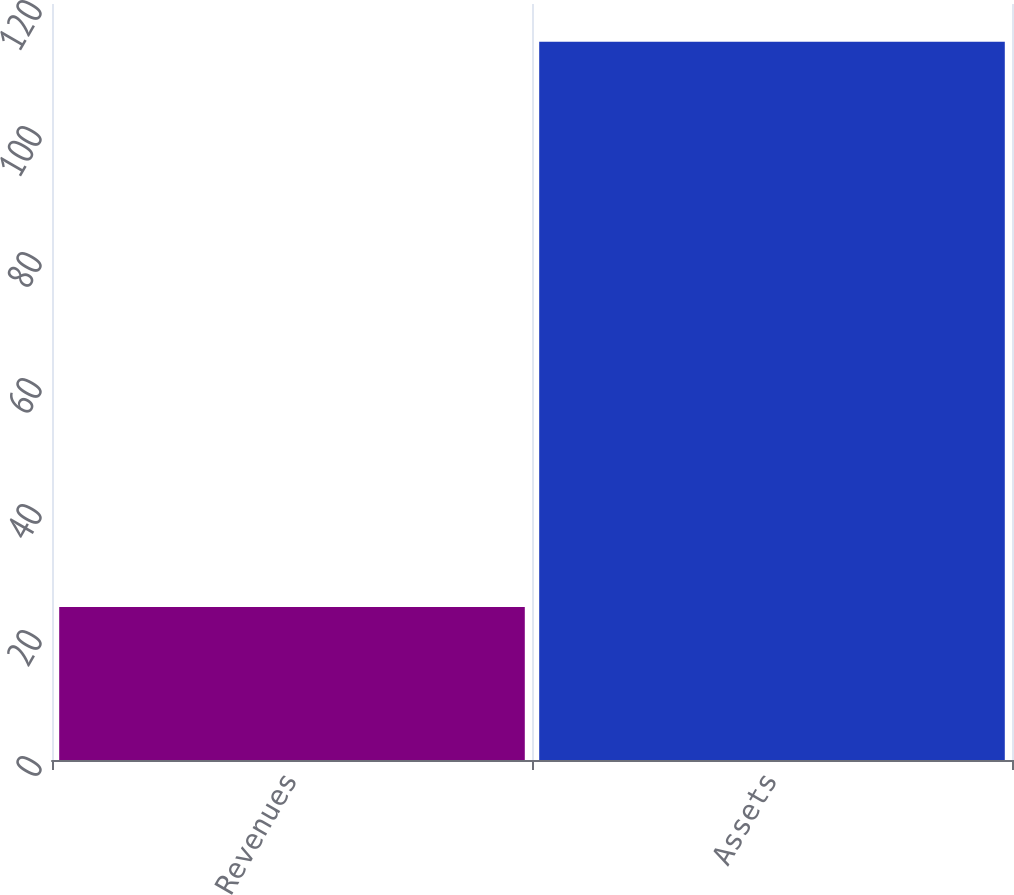<chart> <loc_0><loc_0><loc_500><loc_500><bar_chart><fcel>Revenues<fcel>Assets<nl><fcel>24.3<fcel>114<nl></chart> 